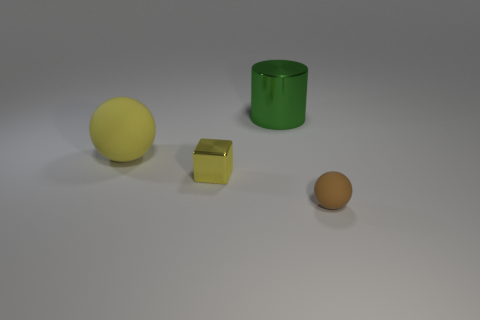Add 4 small gray shiny blocks. How many objects exist? 8 Subtract all cubes. How many objects are left? 3 Subtract all large things. Subtract all large metallic cylinders. How many objects are left? 1 Add 1 small brown objects. How many small brown objects are left? 2 Add 2 brown matte spheres. How many brown matte spheres exist? 3 Subtract 0 blue cylinders. How many objects are left? 4 